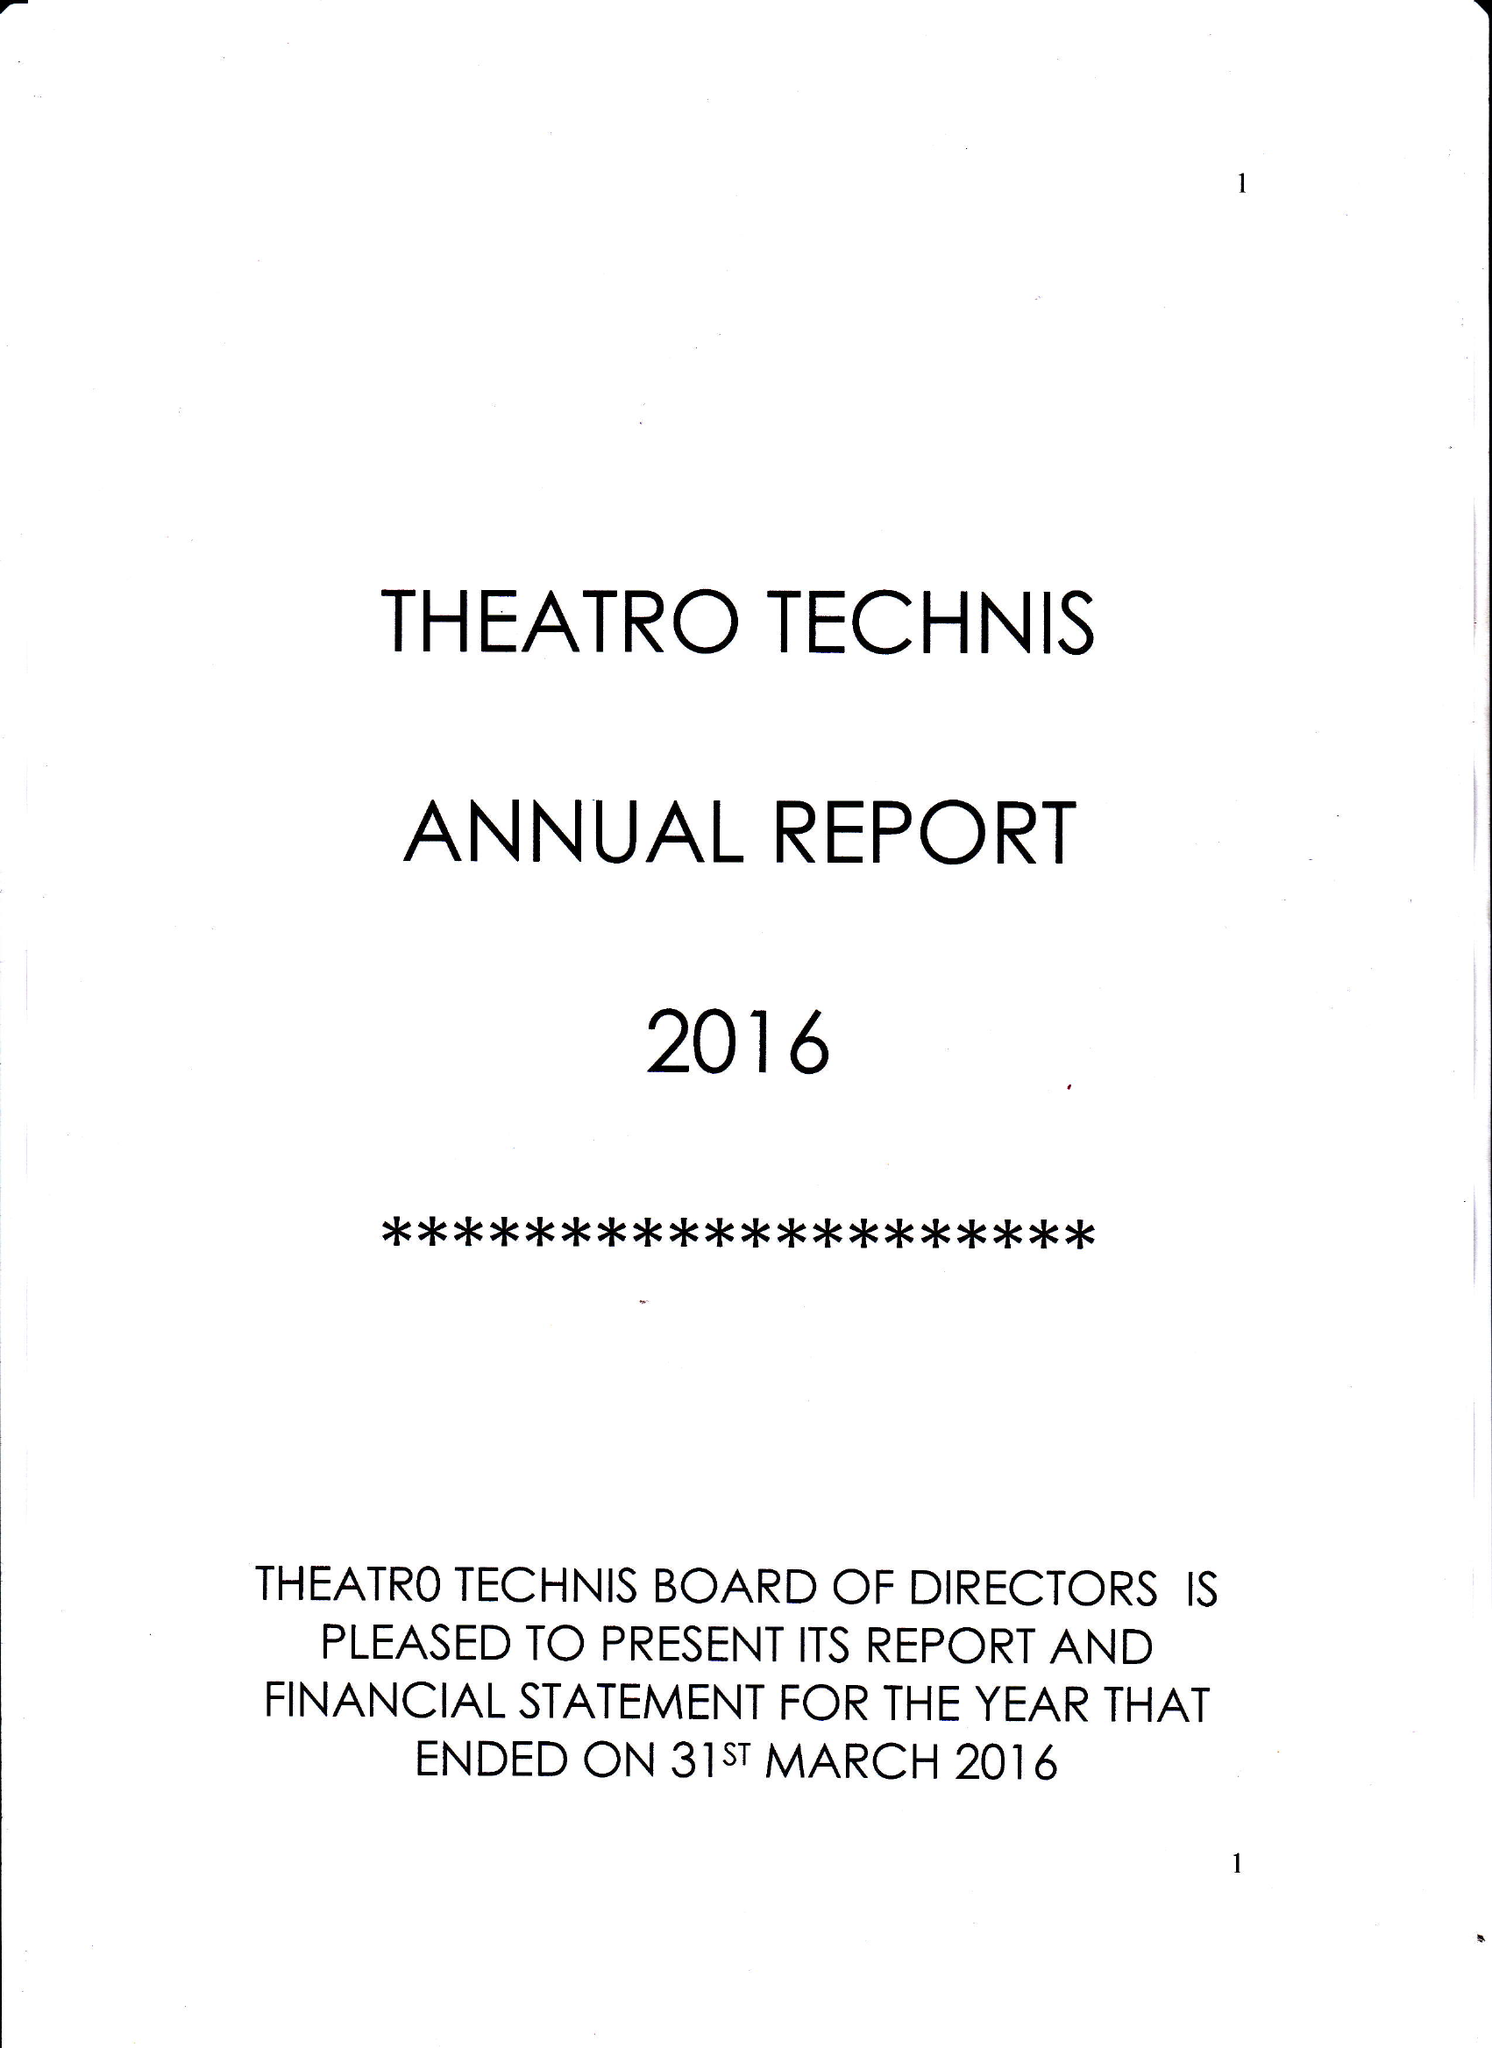What is the value for the income_annually_in_british_pounds?
Answer the question using a single word or phrase. 83510.00 